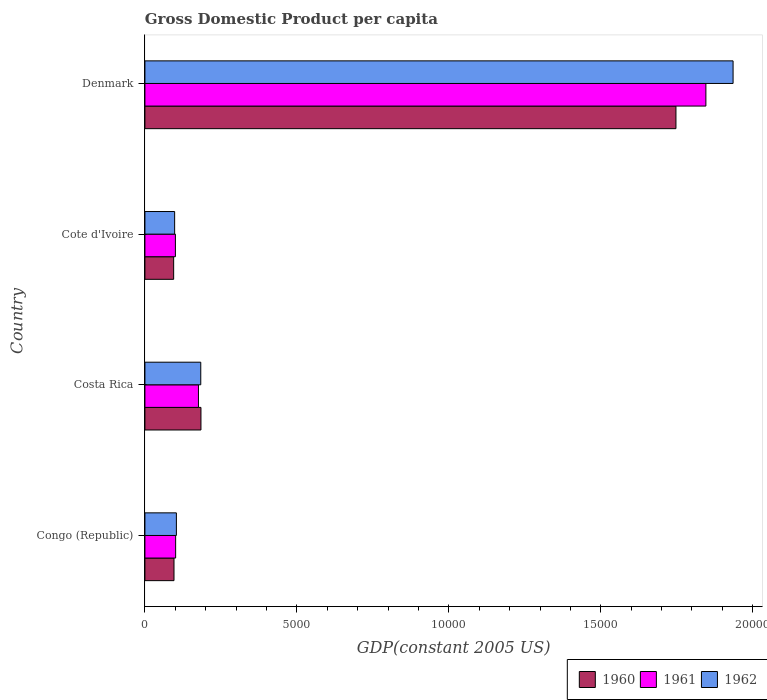How many different coloured bars are there?
Keep it short and to the point. 3. How many groups of bars are there?
Ensure brevity in your answer.  4. Are the number of bars on each tick of the Y-axis equal?
Ensure brevity in your answer.  Yes. How many bars are there on the 3rd tick from the bottom?
Ensure brevity in your answer.  3. What is the label of the 2nd group of bars from the top?
Keep it short and to the point. Cote d'Ivoire. In how many cases, is the number of bars for a given country not equal to the number of legend labels?
Keep it short and to the point. 0. What is the GDP per capita in 1961 in Congo (Republic)?
Ensure brevity in your answer.  1010.58. Across all countries, what is the maximum GDP per capita in 1962?
Give a very brief answer. 1.94e+04. Across all countries, what is the minimum GDP per capita in 1961?
Your answer should be very brief. 1002.94. In which country was the GDP per capita in 1962 minimum?
Offer a very short reply. Cote d'Ivoire. What is the total GDP per capita in 1961 in the graph?
Offer a very short reply. 2.22e+04. What is the difference between the GDP per capita in 1960 in Costa Rica and that in Cote d'Ivoire?
Give a very brief answer. 898.02. What is the difference between the GDP per capita in 1962 in Congo (Republic) and the GDP per capita in 1960 in Cote d'Ivoire?
Make the answer very short. 89.86. What is the average GDP per capita in 1962 per country?
Make the answer very short. 5800.82. What is the difference between the GDP per capita in 1962 and GDP per capita in 1960 in Cote d'Ivoire?
Give a very brief answer. 31.91. What is the ratio of the GDP per capita in 1961 in Cote d'Ivoire to that in Denmark?
Provide a short and direct response. 0.05. Is the GDP per capita in 1960 in Congo (Republic) less than that in Costa Rica?
Offer a terse response. Yes. What is the difference between the highest and the second highest GDP per capita in 1960?
Ensure brevity in your answer.  1.56e+04. What is the difference between the highest and the lowest GDP per capita in 1962?
Offer a very short reply. 1.84e+04. Is the sum of the GDP per capita in 1962 in Costa Rica and Cote d'Ivoire greater than the maximum GDP per capita in 1960 across all countries?
Your answer should be very brief. No. What does the 2nd bar from the bottom in Congo (Republic) represents?
Provide a succinct answer. 1961. How many bars are there?
Ensure brevity in your answer.  12. Are all the bars in the graph horizontal?
Give a very brief answer. Yes. How many countries are there in the graph?
Offer a terse response. 4. What is the title of the graph?
Give a very brief answer. Gross Domestic Product per capita. Does "1961" appear as one of the legend labels in the graph?
Ensure brevity in your answer.  Yes. What is the label or title of the X-axis?
Provide a succinct answer. GDP(constant 2005 US). What is the GDP(constant 2005 US) of 1960 in Congo (Republic)?
Offer a very short reply. 956.97. What is the GDP(constant 2005 US) of 1961 in Congo (Republic)?
Keep it short and to the point. 1010.58. What is the GDP(constant 2005 US) in 1962 in Congo (Republic)?
Provide a short and direct response. 1035.62. What is the GDP(constant 2005 US) in 1960 in Costa Rica?
Give a very brief answer. 1843.78. What is the GDP(constant 2005 US) in 1961 in Costa Rica?
Ensure brevity in your answer.  1761.56. What is the GDP(constant 2005 US) of 1962 in Costa Rica?
Make the answer very short. 1837.73. What is the GDP(constant 2005 US) in 1960 in Cote d'Ivoire?
Provide a succinct answer. 945.76. What is the GDP(constant 2005 US) in 1961 in Cote d'Ivoire?
Give a very brief answer. 1002.94. What is the GDP(constant 2005 US) in 1962 in Cote d'Ivoire?
Provide a short and direct response. 977.67. What is the GDP(constant 2005 US) of 1960 in Denmark?
Provide a succinct answer. 1.75e+04. What is the GDP(constant 2005 US) of 1961 in Denmark?
Your answer should be compact. 1.85e+04. What is the GDP(constant 2005 US) in 1962 in Denmark?
Offer a terse response. 1.94e+04. Across all countries, what is the maximum GDP(constant 2005 US) in 1960?
Your answer should be compact. 1.75e+04. Across all countries, what is the maximum GDP(constant 2005 US) in 1961?
Your answer should be very brief. 1.85e+04. Across all countries, what is the maximum GDP(constant 2005 US) in 1962?
Your response must be concise. 1.94e+04. Across all countries, what is the minimum GDP(constant 2005 US) in 1960?
Your answer should be very brief. 945.76. Across all countries, what is the minimum GDP(constant 2005 US) in 1961?
Provide a short and direct response. 1002.94. Across all countries, what is the minimum GDP(constant 2005 US) in 1962?
Keep it short and to the point. 977.67. What is the total GDP(constant 2005 US) in 1960 in the graph?
Your answer should be compact. 2.12e+04. What is the total GDP(constant 2005 US) of 1961 in the graph?
Offer a very short reply. 2.22e+04. What is the total GDP(constant 2005 US) in 1962 in the graph?
Make the answer very short. 2.32e+04. What is the difference between the GDP(constant 2005 US) in 1960 in Congo (Republic) and that in Costa Rica?
Make the answer very short. -886.81. What is the difference between the GDP(constant 2005 US) of 1961 in Congo (Republic) and that in Costa Rica?
Give a very brief answer. -750.99. What is the difference between the GDP(constant 2005 US) of 1962 in Congo (Republic) and that in Costa Rica?
Keep it short and to the point. -802.11. What is the difference between the GDP(constant 2005 US) in 1960 in Congo (Republic) and that in Cote d'Ivoire?
Your answer should be compact. 11.21. What is the difference between the GDP(constant 2005 US) in 1961 in Congo (Republic) and that in Cote d'Ivoire?
Offer a terse response. 7.64. What is the difference between the GDP(constant 2005 US) in 1962 in Congo (Republic) and that in Cote d'Ivoire?
Make the answer very short. 57.95. What is the difference between the GDP(constant 2005 US) in 1960 in Congo (Republic) and that in Denmark?
Give a very brief answer. -1.65e+04. What is the difference between the GDP(constant 2005 US) of 1961 in Congo (Republic) and that in Denmark?
Provide a succinct answer. -1.74e+04. What is the difference between the GDP(constant 2005 US) of 1962 in Congo (Republic) and that in Denmark?
Your answer should be very brief. -1.83e+04. What is the difference between the GDP(constant 2005 US) of 1960 in Costa Rica and that in Cote d'Ivoire?
Keep it short and to the point. 898.02. What is the difference between the GDP(constant 2005 US) of 1961 in Costa Rica and that in Cote d'Ivoire?
Offer a terse response. 758.62. What is the difference between the GDP(constant 2005 US) in 1962 in Costa Rica and that in Cote d'Ivoire?
Provide a short and direct response. 860.05. What is the difference between the GDP(constant 2005 US) of 1960 in Costa Rica and that in Denmark?
Give a very brief answer. -1.56e+04. What is the difference between the GDP(constant 2005 US) of 1961 in Costa Rica and that in Denmark?
Keep it short and to the point. -1.67e+04. What is the difference between the GDP(constant 2005 US) of 1962 in Costa Rica and that in Denmark?
Ensure brevity in your answer.  -1.75e+04. What is the difference between the GDP(constant 2005 US) in 1960 in Cote d'Ivoire and that in Denmark?
Offer a very short reply. -1.65e+04. What is the difference between the GDP(constant 2005 US) of 1961 in Cote d'Ivoire and that in Denmark?
Make the answer very short. -1.75e+04. What is the difference between the GDP(constant 2005 US) in 1962 in Cote d'Ivoire and that in Denmark?
Ensure brevity in your answer.  -1.84e+04. What is the difference between the GDP(constant 2005 US) in 1960 in Congo (Republic) and the GDP(constant 2005 US) in 1961 in Costa Rica?
Your response must be concise. -804.59. What is the difference between the GDP(constant 2005 US) in 1960 in Congo (Republic) and the GDP(constant 2005 US) in 1962 in Costa Rica?
Provide a short and direct response. -880.76. What is the difference between the GDP(constant 2005 US) of 1961 in Congo (Republic) and the GDP(constant 2005 US) of 1962 in Costa Rica?
Keep it short and to the point. -827.15. What is the difference between the GDP(constant 2005 US) of 1960 in Congo (Republic) and the GDP(constant 2005 US) of 1961 in Cote d'Ivoire?
Your answer should be very brief. -45.97. What is the difference between the GDP(constant 2005 US) in 1960 in Congo (Republic) and the GDP(constant 2005 US) in 1962 in Cote d'Ivoire?
Provide a succinct answer. -20.7. What is the difference between the GDP(constant 2005 US) of 1961 in Congo (Republic) and the GDP(constant 2005 US) of 1962 in Cote d'Ivoire?
Provide a short and direct response. 32.9. What is the difference between the GDP(constant 2005 US) of 1960 in Congo (Republic) and the GDP(constant 2005 US) of 1961 in Denmark?
Offer a very short reply. -1.75e+04. What is the difference between the GDP(constant 2005 US) of 1960 in Congo (Republic) and the GDP(constant 2005 US) of 1962 in Denmark?
Provide a short and direct response. -1.84e+04. What is the difference between the GDP(constant 2005 US) in 1961 in Congo (Republic) and the GDP(constant 2005 US) in 1962 in Denmark?
Your answer should be compact. -1.83e+04. What is the difference between the GDP(constant 2005 US) in 1960 in Costa Rica and the GDP(constant 2005 US) in 1961 in Cote d'Ivoire?
Offer a very short reply. 840.84. What is the difference between the GDP(constant 2005 US) in 1960 in Costa Rica and the GDP(constant 2005 US) in 1962 in Cote d'Ivoire?
Make the answer very short. 866.11. What is the difference between the GDP(constant 2005 US) in 1961 in Costa Rica and the GDP(constant 2005 US) in 1962 in Cote d'Ivoire?
Keep it short and to the point. 783.89. What is the difference between the GDP(constant 2005 US) in 1960 in Costa Rica and the GDP(constant 2005 US) in 1961 in Denmark?
Ensure brevity in your answer.  -1.66e+04. What is the difference between the GDP(constant 2005 US) of 1960 in Costa Rica and the GDP(constant 2005 US) of 1962 in Denmark?
Keep it short and to the point. -1.75e+04. What is the difference between the GDP(constant 2005 US) of 1961 in Costa Rica and the GDP(constant 2005 US) of 1962 in Denmark?
Your answer should be very brief. -1.76e+04. What is the difference between the GDP(constant 2005 US) in 1960 in Cote d'Ivoire and the GDP(constant 2005 US) in 1961 in Denmark?
Ensure brevity in your answer.  -1.75e+04. What is the difference between the GDP(constant 2005 US) in 1960 in Cote d'Ivoire and the GDP(constant 2005 US) in 1962 in Denmark?
Offer a terse response. -1.84e+04. What is the difference between the GDP(constant 2005 US) in 1961 in Cote d'Ivoire and the GDP(constant 2005 US) in 1962 in Denmark?
Make the answer very short. -1.83e+04. What is the average GDP(constant 2005 US) of 1960 per country?
Make the answer very short. 5304.71. What is the average GDP(constant 2005 US) in 1961 per country?
Ensure brevity in your answer.  5558.16. What is the average GDP(constant 2005 US) of 1962 per country?
Offer a terse response. 5800.82. What is the difference between the GDP(constant 2005 US) in 1960 and GDP(constant 2005 US) in 1961 in Congo (Republic)?
Make the answer very short. -53.61. What is the difference between the GDP(constant 2005 US) in 1960 and GDP(constant 2005 US) in 1962 in Congo (Republic)?
Give a very brief answer. -78.65. What is the difference between the GDP(constant 2005 US) of 1961 and GDP(constant 2005 US) of 1962 in Congo (Republic)?
Your answer should be compact. -25.04. What is the difference between the GDP(constant 2005 US) in 1960 and GDP(constant 2005 US) in 1961 in Costa Rica?
Give a very brief answer. 82.22. What is the difference between the GDP(constant 2005 US) of 1960 and GDP(constant 2005 US) of 1962 in Costa Rica?
Offer a terse response. 6.05. What is the difference between the GDP(constant 2005 US) in 1961 and GDP(constant 2005 US) in 1962 in Costa Rica?
Make the answer very short. -76.16. What is the difference between the GDP(constant 2005 US) in 1960 and GDP(constant 2005 US) in 1961 in Cote d'Ivoire?
Make the answer very short. -57.18. What is the difference between the GDP(constant 2005 US) in 1960 and GDP(constant 2005 US) in 1962 in Cote d'Ivoire?
Give a very brief answer. -31.91. What is the difference between the GDP(constant 2005 US) of 1961 and GDP(constant 2005 US) of 1962 in Cote d'Ivoire?
Your answer should be compact. 25.27. What is the difference between the GDP(constant 2005 US) of 1960 and GDP(constant 2005 US) of 1961 in Denmark?
Your answer should be compact. -985.22. What is the difference between the GDP(constant 2005 US) of 1960 and GDP(constant 2005 US) of 1962 in Denmark?
Your response must be concise. -1879.94. What is the difference between the GDP(constant 2005 US) in 1961 and GDP(constant 2005 US) in 1962 in Denmark?
Ensure brevity in your answer.  -894.72. What is the ratio of the GDP(constant 2005 US) of 1960 in Congo (Republic) to that in Costa Rica?
Ensure brevity in your answer.  0.52. What is the ratio of the GDP(constant 2005 US) in 1961 in Congo (Republic) to that in Costa Rica?
Keep it short and to the point. 0.57. What is the ratio of the GDP(constant 2005 US) in 1962 in Congo (Republic) to that in Costa Rica?
Your answer should be compact. 0.56. What is the ratio of the GDP(constant 2005 US) of 1960 in Congo (Republic) to that in Cote d'Ivoire?
Give a very brief answer. 1.01. What is the ratio of the GDP(constant 2005 US) of 1961 in Congo (Republic) to that in Cote d'Ivoire?
Offer a terse response. 1.01. What is the ratio of the GDP(constant 2005 US) of 1962 in Congo (Republic) to that in Cote d'Ivoire?
Your response must be concise. 1.06. What is the ratio of the GDP(constant 2005 US) in 1960 in Congo (Republic) to that in Denmark?
Your response must be concise. 0.05. What is the ratio of the GDP(constant 2005 US) of 1961 in Congo (Republic) to that in Denmark?
Give a very brief answer. 0.05. What is the ratio of the GDP(constant 2005 US) of 1962 in Congo (Republic) to that in Denmark?
Make the answer very short. 0.05. What is the ratio of the GDP(constant 2005 US) in 1960 in Costa Rica to that in Cote d'Ivoire?
Provide a succinct answer. 1.95. What is the ratio of the GDP(constant 2005 US) of 1961 in Costa Rica to that in Cote d'Ivoire?
Provide a succinct answer. 1.76. What is the ratio of the GDP(constant 2005 US) of 1962 in Costa Rica to that in Cote d'Ivoire?
Offer a terse response. 1.88. What is the ratio of the GDP(constant 2005 US) of 1960 in Costa Rica to that in Denmark?
Your response must be concise. 0.11. What is the ratio of the GDP(constant 2005 US) in 1961 in Costa Rica to that in Denmark?
Offer a very short reply. 0.1. What is the ratio of the GDP(constant 2005 US) of 1962 in Costa Rica to that in Denmark?
Your answer should be very brief. 0.1. What is the ratio of the GDP(constant 2005 US) in 1960 in Cote d'Ivoire to that in Denmark?
Provide a succinct answer. 0.05. What is the ratio of the GDP(constant 2005 US) in 1961 in Cote d'Ivoire to that in Denmark?
Offer a terse response. 0.05. What is the ratio of the GDP(constant 2005 US) in 1962 in Cote d'Ivoire to that in Denmark?
Offer a very short reply. 0.05. What is the difference between the highest and the second highest GDP(constant 2005 US) in 1960?
Offer a terse response. 1.56e+04. What is the difference between the highest and the second highest GDP(constant 2005 US) in 1961?
Make the answer very short. 1.67e+04. What is the difference between the highest and the second highest GDP(constant 2005 US) of 1962?
Provide a short and direct response. 1.75e+04. What is the difference between the highest and the lowest GDP(constant 2005 US) in 1960?
Ensure brevity in your answer.  1.65e+04. What is the difference between the highest and the lowest GDP(constant 2005 US) of 1961?
Your answer should be very brief. 1.75e+04. What is the difference between the highest and the lowest GDP(constant 2005 US) of 1962?
Your answer should be compact. 1.84e+04. 